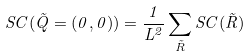<formula> <loc_0><loc_0><loc_500><loc_500>S C ( \vec { Q } = ( 0 , 0 ) ) = \frac { 1 } { L ^ { 2 } } \sum _ { \vec { R } } S C ( \vec { R } )</formula> 